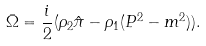Convert formula to latex. <formula><loc_0><loc_0><loc_500><loc_500>\bar { \Omega } = { \frac { i } { 2 } } ( { \rho } _ { 2 } { \hat { \pi } } - { \rho } _ { 1 } ( P ^ { 2 } - m ^ { 2 } ) ) .</formula> 